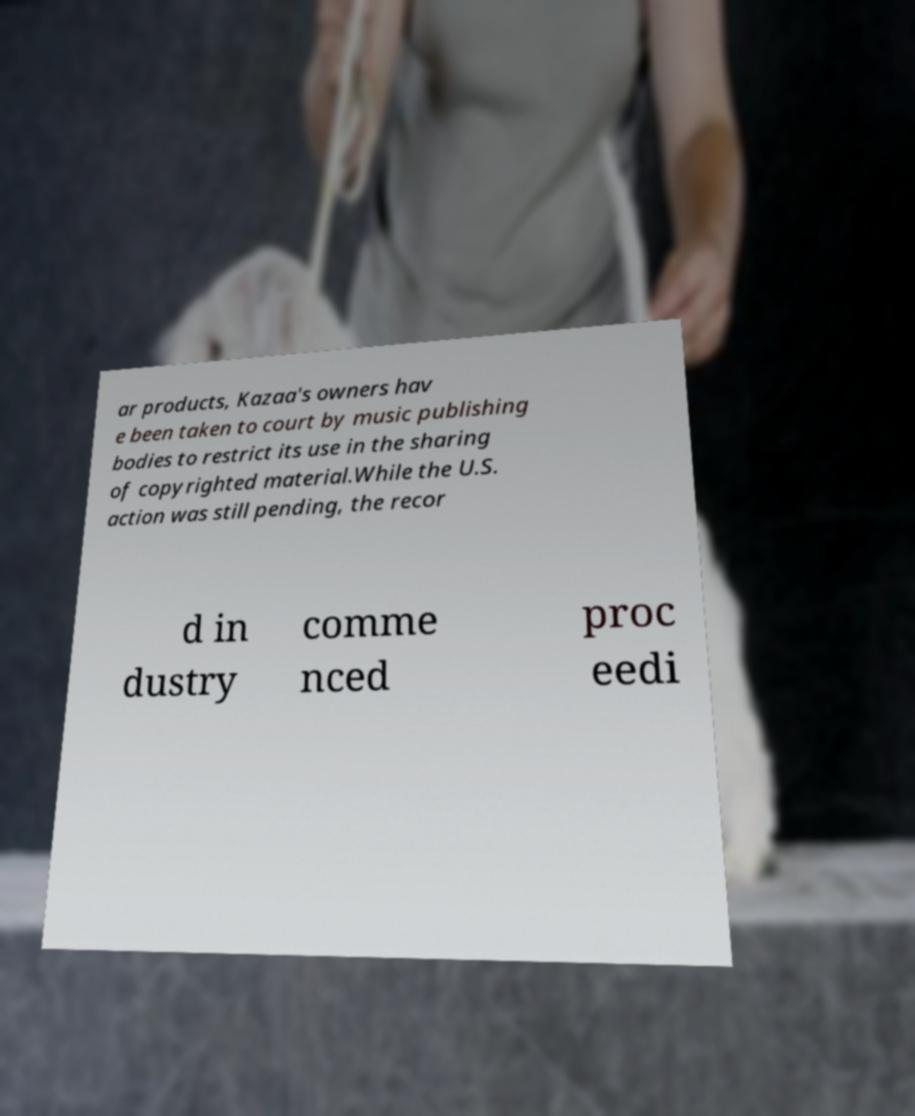I need the written content from this picture converted into text. Can you do that? ar products, Kazaa's owners hav e been taken to court by music publishing bodies to restrict its use in the sharing of copyrighted material.While the U.S. action was still pending, the recor d in dustry comme nced proc eedi 